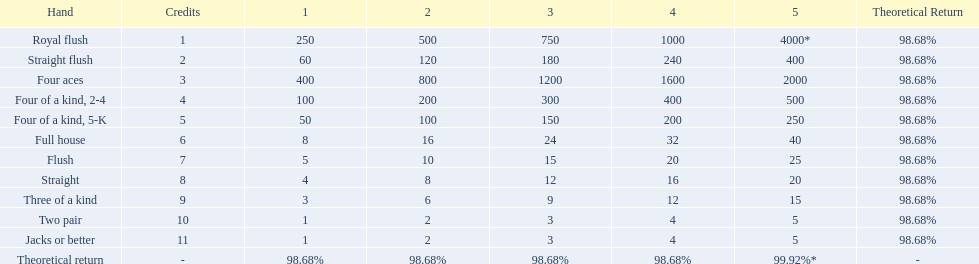What is the values in the 5 credits area? 4000*, 400, 2000, 500, 250, 40, 25, 20, 15, 5, 5. Which of these is for a four of a kind? 500, 250. What is the higher value? 500. What hand is this for Four of a kind, 2-4. 